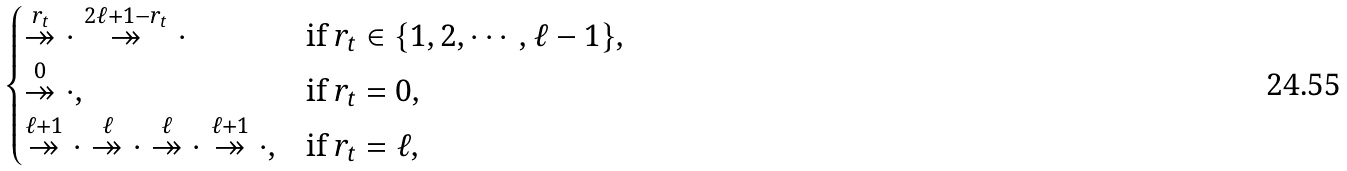<formula> <loc_0><loc_0><loc_500><loc_500>\begin{cases} \overset { r _ { t } } { \twoheadrightarrow } \cdot \overset { 2 \ell + 1 - r _ { t } } { \twoheadrightarrow } \cdot & \text {if $r_{t}\in\{1,2,\cdots,\ell-1\}$,} \\ \overset { 0 } { \twoheadrightarrow } \cdot , & \text {if $r_{t}=0$,} \\ \overset { \ell + 1 } { \twoheadrightarrow } \cdot \overset { \ell } { \twoheadrightarrow } \cdot \overset { \ell } { \twoheadrightarrow } \cdot \overset { \ell + 1 } { \twoheadrightarrow } \cdot , & \text {if $r_{t}=\ell$,} \end{cases}</formula> 